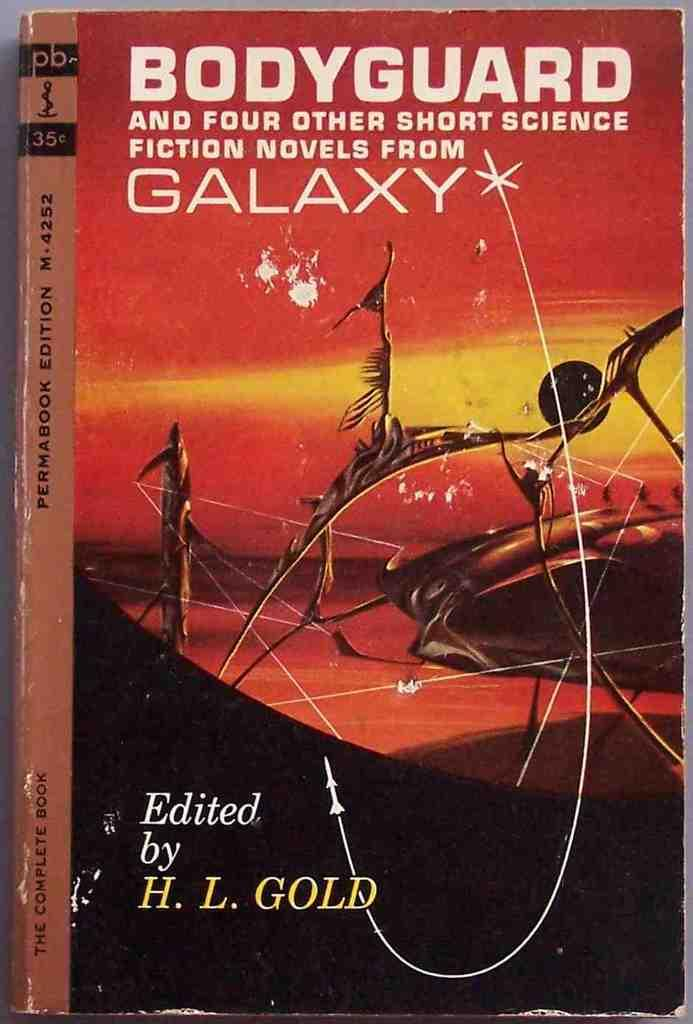<image>
Provide a brief description of the given image. A paperback anthology of novels edited by H.L. Gold. 